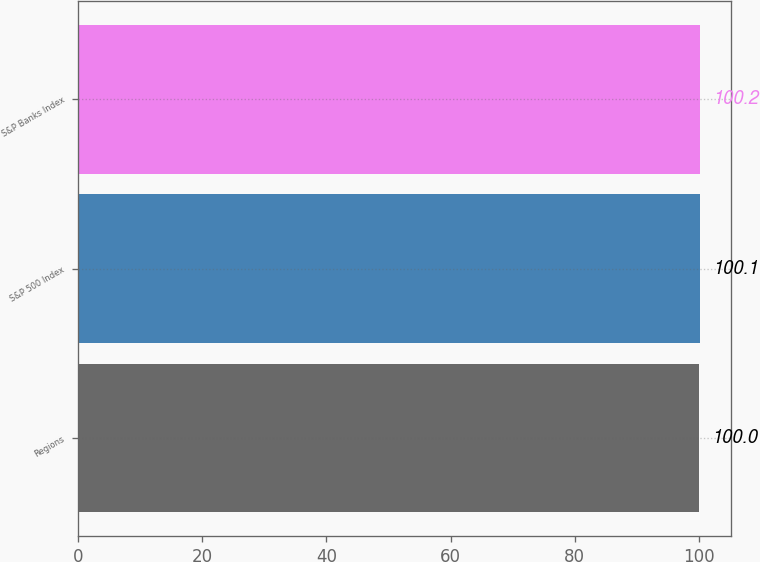Convert chart to OTSL. <chart><loc_0><loc_0><loc_500><loc_500><bar_chart><fcel>Regions<fcel>S&P 500 Index<fcel>S&P Banks Index<nl><fcel>100<fcel>100.1<fcel>100.2<nl></chart> 